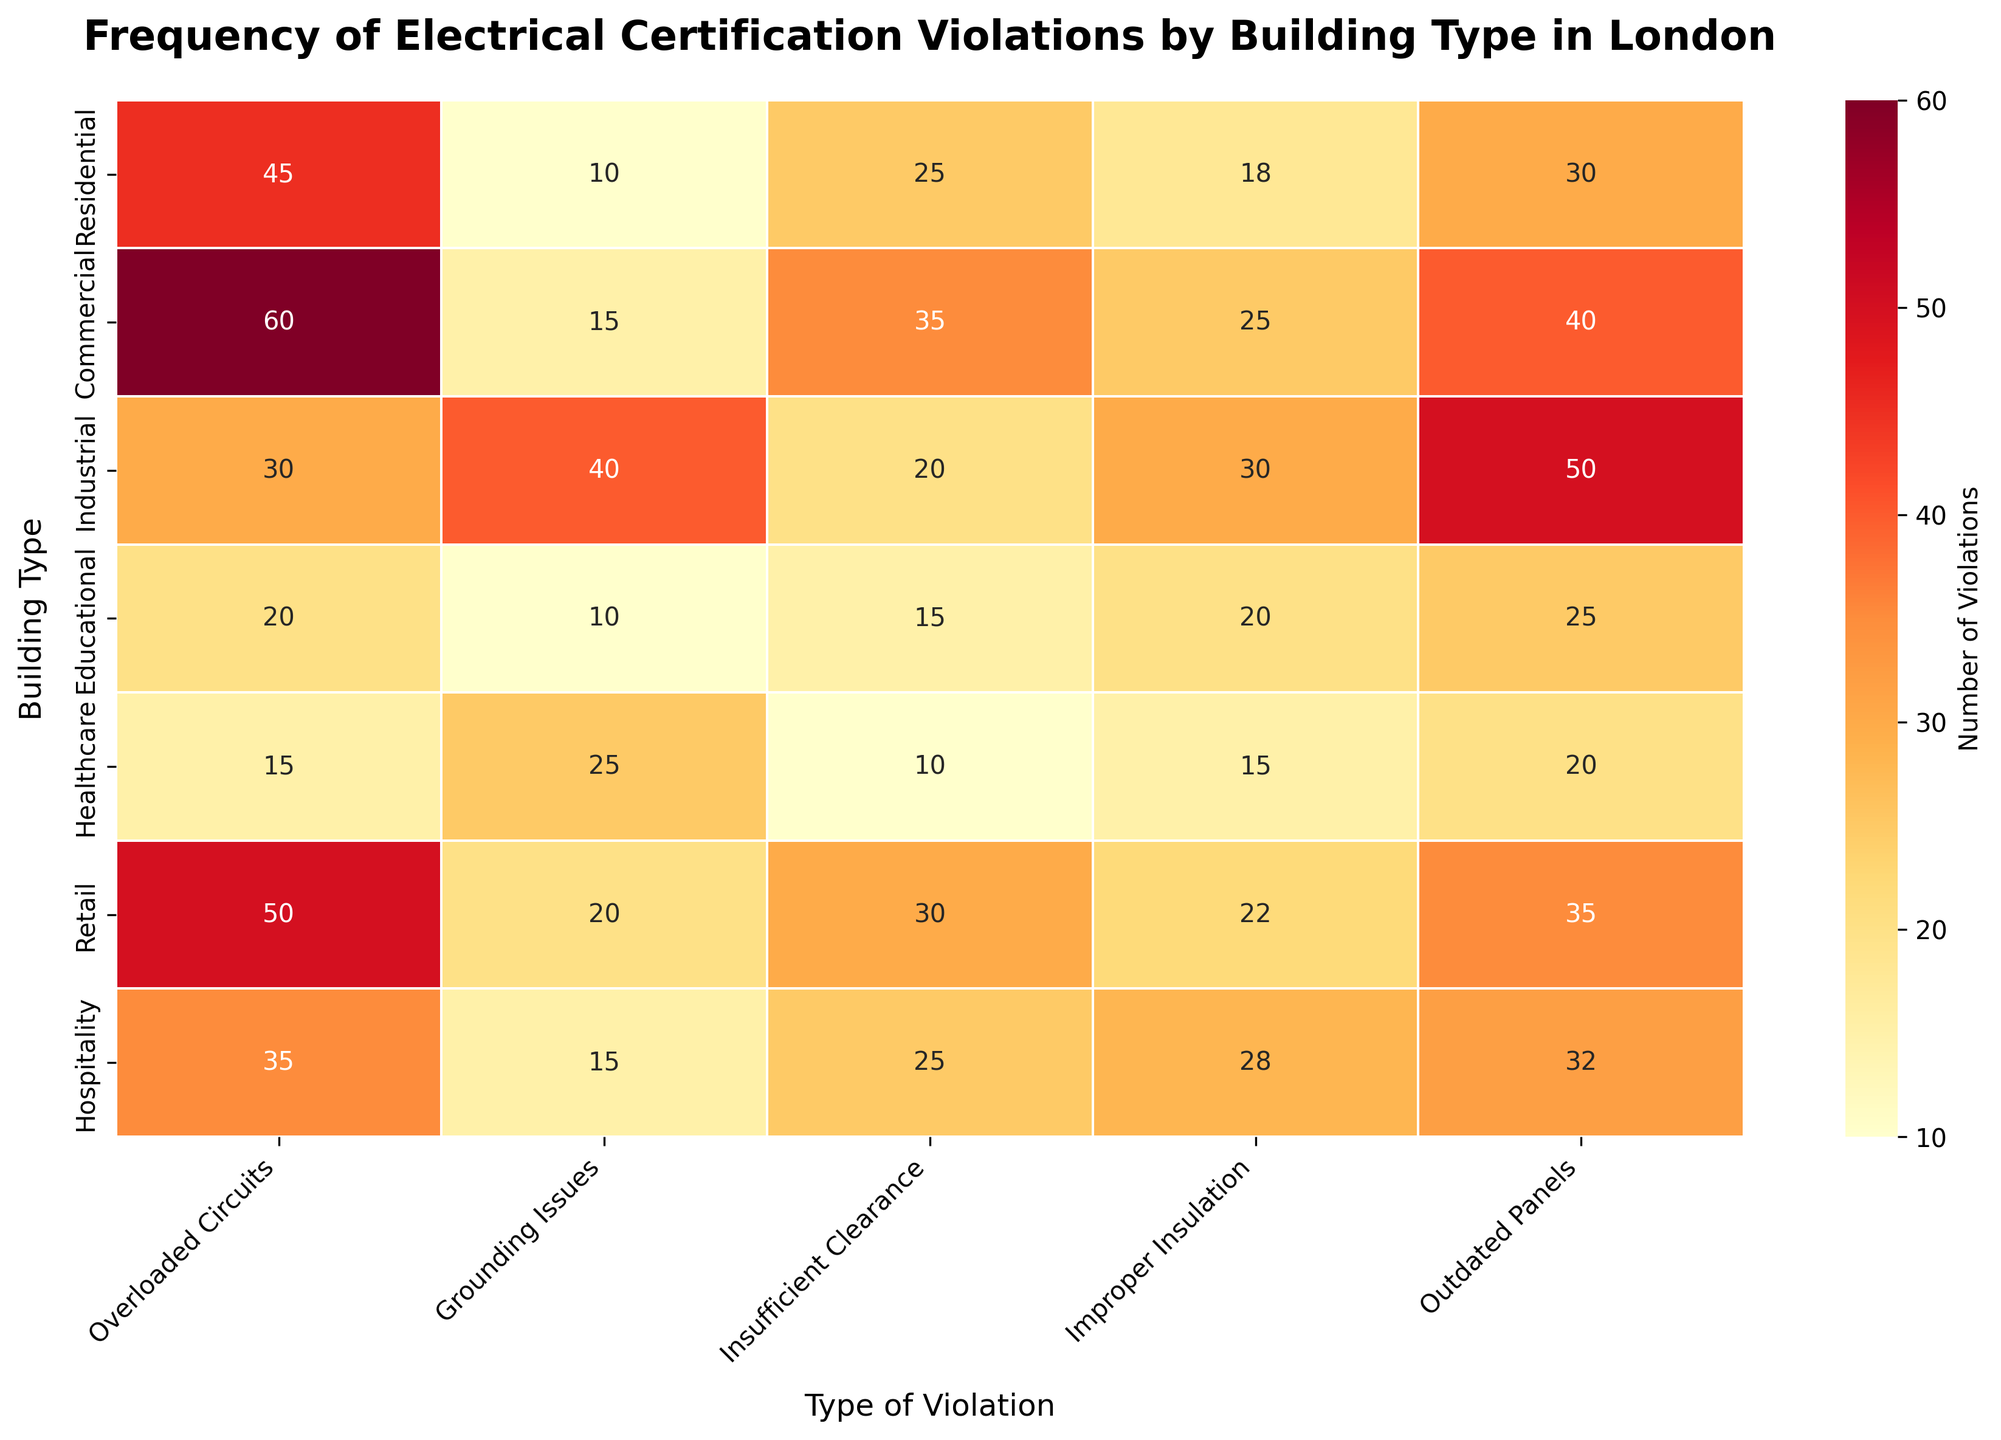What is the most common type of violation in residential buildings? Check the cell under "Residential" for each type of violation and identify the highest number. The highest number under "Residential" is 45 for "Overloaded Circuits".
Answer: Overloaded Circuits Which building type has the least number of grounding issues? Look for the lowest value in the "Grounding Issues" column. The lowest value in this column is 10, which corresponds to "Residential" and "Educational" buildings.
Answer: Residential, Educational How many total violations of "Improper Insulation" are there across all building types? Sum the numbers in the "Improper Insulation" column: 18 (Residential) + 25 (Commercial) + 30 (Industrial) + 20 (Educational) + 15 (Healthcare) + 22 (Retail) + 28 (Hospitality) = 158.
Answer: 158 What type of violation has the highest frequency in commercial buildings? Identify the highest number in the "Commercial" row. The highest number is 60 for "Overloaded Circuits".
Answer: Overloaded Circuits Which two building types have exactly equal counts of any violation type? Identify building types with identical numbers for the same type of violation; "Residential" and "Educational" both have 10 violations of "Grounding Issues".
Answer: Residential and Educational How many more "Grounding Issues" are there in industrial buildings compared to residential buildings? Subtract the number of "Grounding Issues" in "Residential" from "Industrial": 40 (Industrial) - 10 (Residential) = 30.
Answer: 30 What is the least common type of violation in industrial buildings? Check the cell under "Industrial" for each type of violation and identify the lowest number. The lowest number is 20 for "Insufficient Clearance".
Answer: Insufficient Clearance How many violations are reported for healthcare buildings in total across all types? Sum the numbers across the "Healthcare" row: 15 (Overloaded Circuits) + 25 (Grounding Issues) + 10 (Insufficient Clearance) + 15 (Improper Insulation) + 20 (Outdated Panels) = 85.
Answer: 85 Which building type has the highest total number of violations? Sum the violations for each building type and compare the results. The totals are: 
Residential: 128 (45+10+25+18+30) 
Commercial: 175 (60+15+35+25+40) 
Industrial: 170 (30+40+20+30+50) 
Educational: 90 (20+10+15+20+25) 
Healthcare: 85 (15+25+10+15+20) 
Retail: 157 (50+20+30+22+35) 
Hospitality: 135 (35+15+25+28+32) 
The highest total is for "Commercial" with 175.
Answer: Commercial Which violation type has the most total occurrences? Sum the numbers for each type of violation and compare: 
Overloaded Circuits: 255 (45+60+30+20+15+50+35) 
Grounding Issues: 135 (10+15+40+10+25+20+15) 
Insufficient Clearance: 160 (25+35+20+15+10+30+25) 
Improper Insulation: 158 (18+25+30+20+15+22+28) 
Outdated Panels: 232 (30+40+50+25+20+35+32) 
"Overloaded Circuits" has the highest total with 255 occurrences.
Answer: Overloaded Circuits 